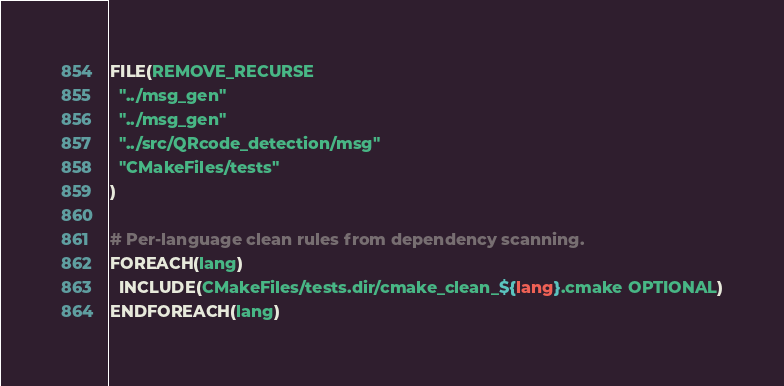<code> <loc_0><loc_0><loc_500><loc_500><_CMake_>FILE(REMOVE_RECURSE
  "../msg_gen"
  "../msg_gen"
  "../src/QRcode_detection/msg"
  "CMakeFiles/tests"
)

# Per-language clean rules from dependency scanning.
FOREACH(lang)
  INCLUDE(CMakeFiles/tests.dir/cmake_clean_${lang}.cmake OPTIONAL)
ENDFOREACH(lang)
</code> 